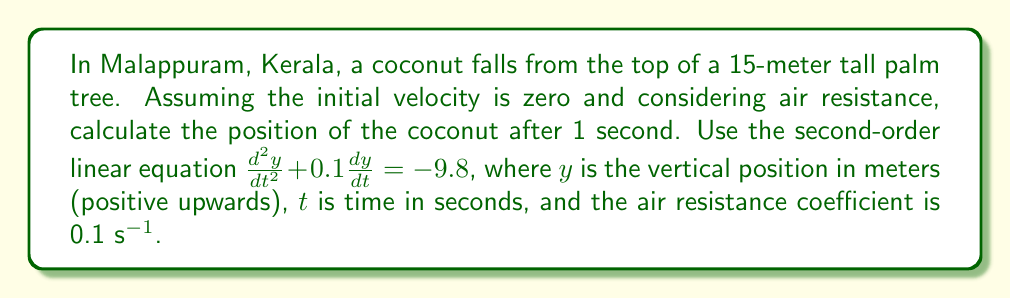Provide a solution to this math problem. To solve this problem, we need to follow these steps:

1) The given second-order linear equation is:

   $$\frac{d^2y}{dt^2} + 0.1\frac{dy}{dt} = -9.8$$

2) We need to solve this differential equation with the initial conditions:
   $y(0) = 15$ (initial height)
   $\frac{dy}{dt}(0) = 0$ (initial velocity)

3) The general solution to this equation is:

   $$y(t) = c_1e^{-0.1t} + c_2 + 98t$$

4) To find $c_1$ and $c_2$, we use the initial conditions:

   At $t=0$: $y(0) = c_1 + c_2 = 15$
   At $t=0$: $\frac{dy}{dt}(0) = -0.1c_1 + 98 = 0$

5) From the second equation: $c_1 = 980$

6) Substituting this into the first equation:
   $980 + c_2 = 15$
   $c_2 = -965$

7) Therefore, the particular solution is:

   $$y(t) = 980e^{-0.1t} - 965 + 98t$$

8) To find the position after 1 second, we substitute $t=1$:

   $$y(1) = 980e^{-0.1} - 965 + 98$$

9) Calculating this:

   $$y(1) \approx 980 * 0.9048 - 965 + 98 \approx 14.704$$

Therefore, after 1 second, the coconut is approximately 14.704 meters above the ground.
Answer: $y(1) \approx 14.704$ meters 